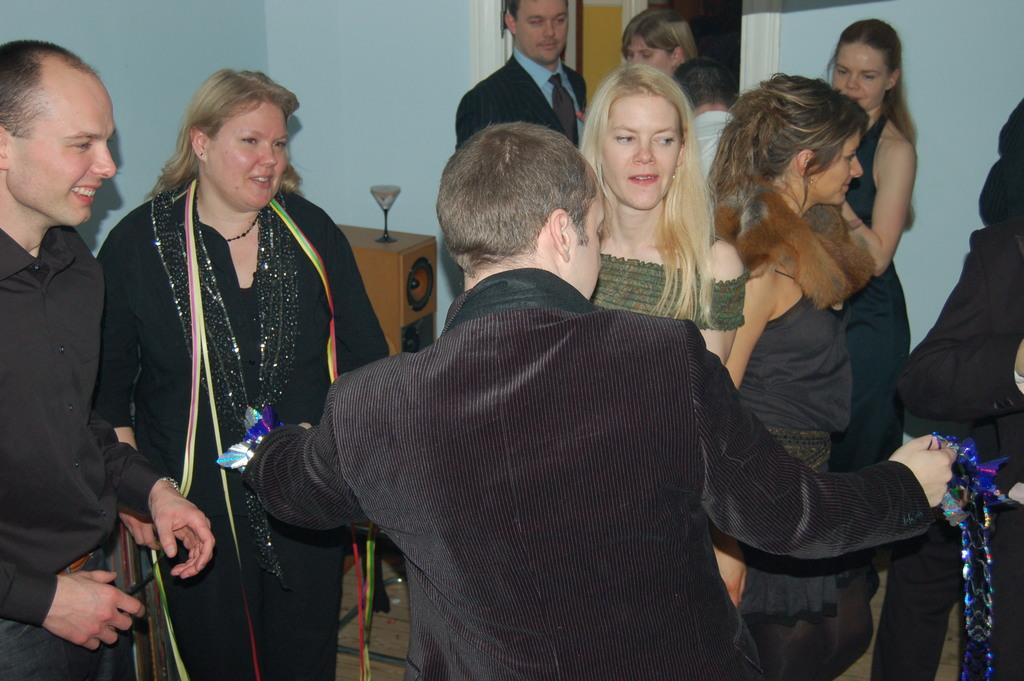Who or what can be seen in the image? There are people in the image. What object is placed on a speaker in the image? There is a glass on a speaker in the image. What can be seen in the background of the image? There is a wall in the background of the image. What type of plastic can be seen floating in the drain in the image? There is no drain or plastic present in the image. Can you read the note that is attached to the wall in the image? There is no note attached to the wall in the image. 